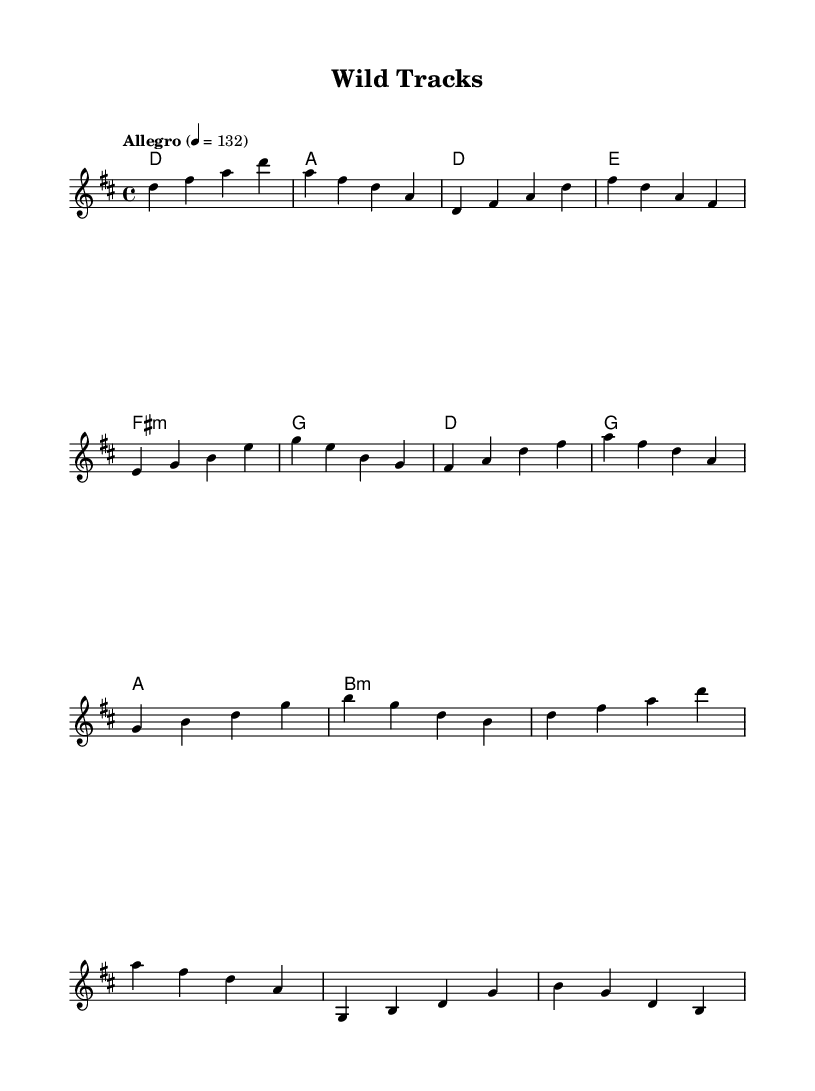What is the key signature of this music? The key signature is indicated by the presence of two sharps (F# and C#) in the music, which defines it as D major.
Answer: D major What is the time signature of this music? The time signature is shown at the beginning of the score as a fraction, which is 4/4, indicating four beats per measure.
Answer: 4/4 What is the tempo marking for this piece? The tempo marking is indicated in the score, stating "Allegro" with a metronome marking of 132 beats per minute.
Answer: Allegro 132 How many measures are in the chorus section? By analyzing the sheet music, the chorus is composed of two measures, each containing a repetition of the melodic phrase.
Answer: 2 measures What is the harmonic quality of the pre-chorus chord? The chord indicated in the pre-chorus section is a minor chord, shown by the notation "fis1:m," which specifies it as F# minor.
Answer: F# minor Which section contains a repeated melodic phrase? The chorus section exhibits a repetitive melodic structure, as the same melody is reiterated within the measures, signifying a typical K-Pop choruses.
Answer: Chorus 